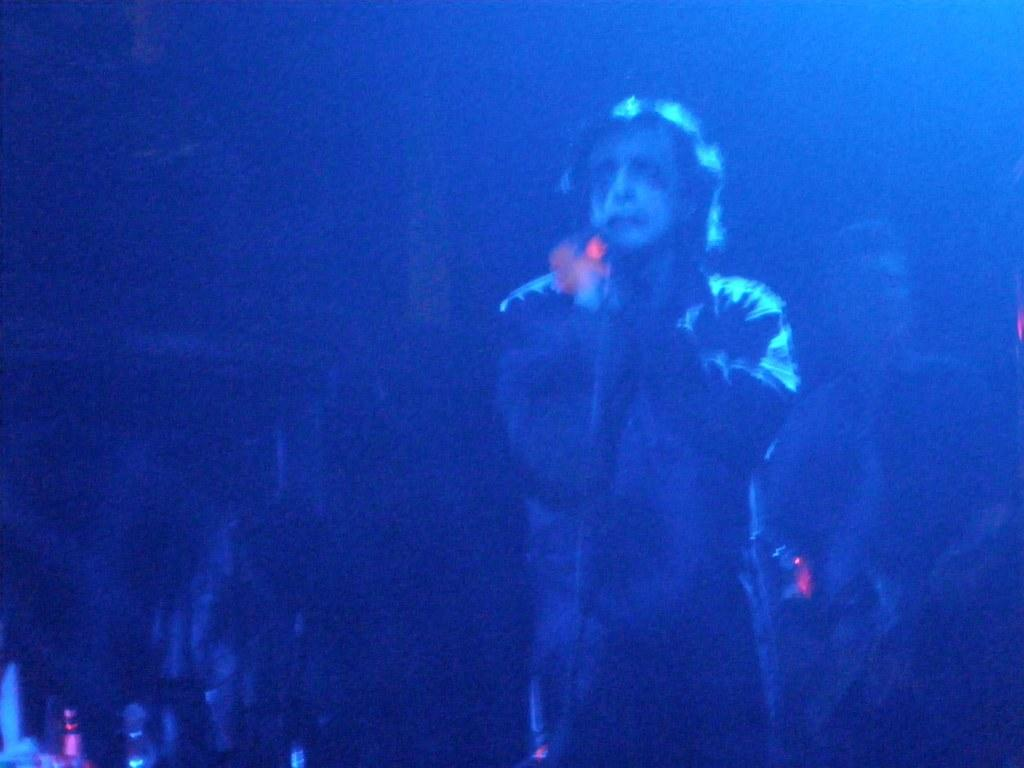What is the overall lighting condition in the image? The image is dark. How many people are visible in the image? There are two persons standing on the right side of the image. What color tone is dominant in the image? The image has a blue color tone. What type of wax is being used by the person on the left side of the image? There is no person on the left side of the image, and no wax is visible in the image. 